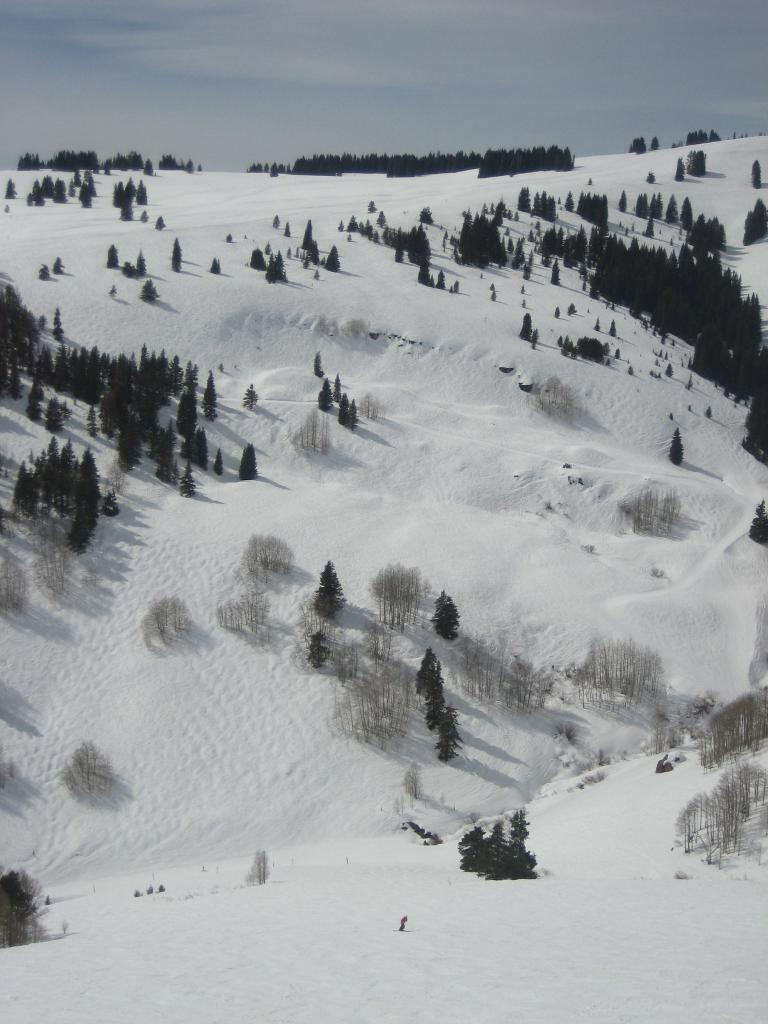What is the primary color of the snow in the image? The snow in the image is white in color. What type of natural elements can be seen in the image? There are many trees in the image. What part of the natural environment is visible in the image? The sky is visible in the image. How much sugar is present in the snow in the image? There is no sugar present in the snow in the image, as it is a natural occurrence of frozen water. 